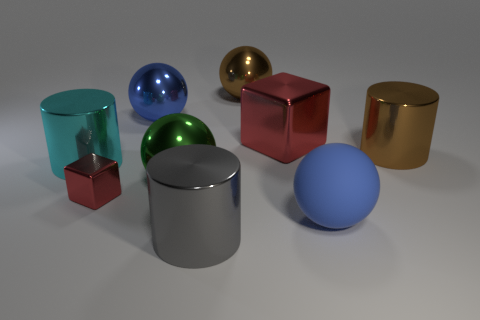What is the material of the big blue sphere that is behind the small metallic cube?
Offer a very short reply. Metal. What material is the large ball that is the same color as the large rubber thing?
Keep it short and to the point. Metal. How many big objects are either red metal blocks or gray cylinders?
Your answer should be very brief. 2. The big matte sphere has what color?
Ensure brevity in your answer.  Blue. Is there a blue metal sphere that is behind the blue metallic sphere that is to the left of the large green sphere?
Give a very brief answer. No. Is the number of brown cylinders that are on the left side of the large red cube less than the number of large brown shiny objects?
Your answer should be compact. Yes. Are the cylinder right of the gray object and the big gray cylinder made of the same material?
Your answer should be compact. Yes. There is a large cube that is made of the same material as the green ball; what is its color?
Keep it short and to the point. Red. Is the number of large metal objects right of the tiny metal thing less than the number of big blue things that are to the right of the large brown cylinder?
Provide a short and direct response. No. Is the color of the sphere that is in front of the small metal cube the same as the metallic cube that is behind the tiny shiny object?
Ensure brevity in your answer.  No. 